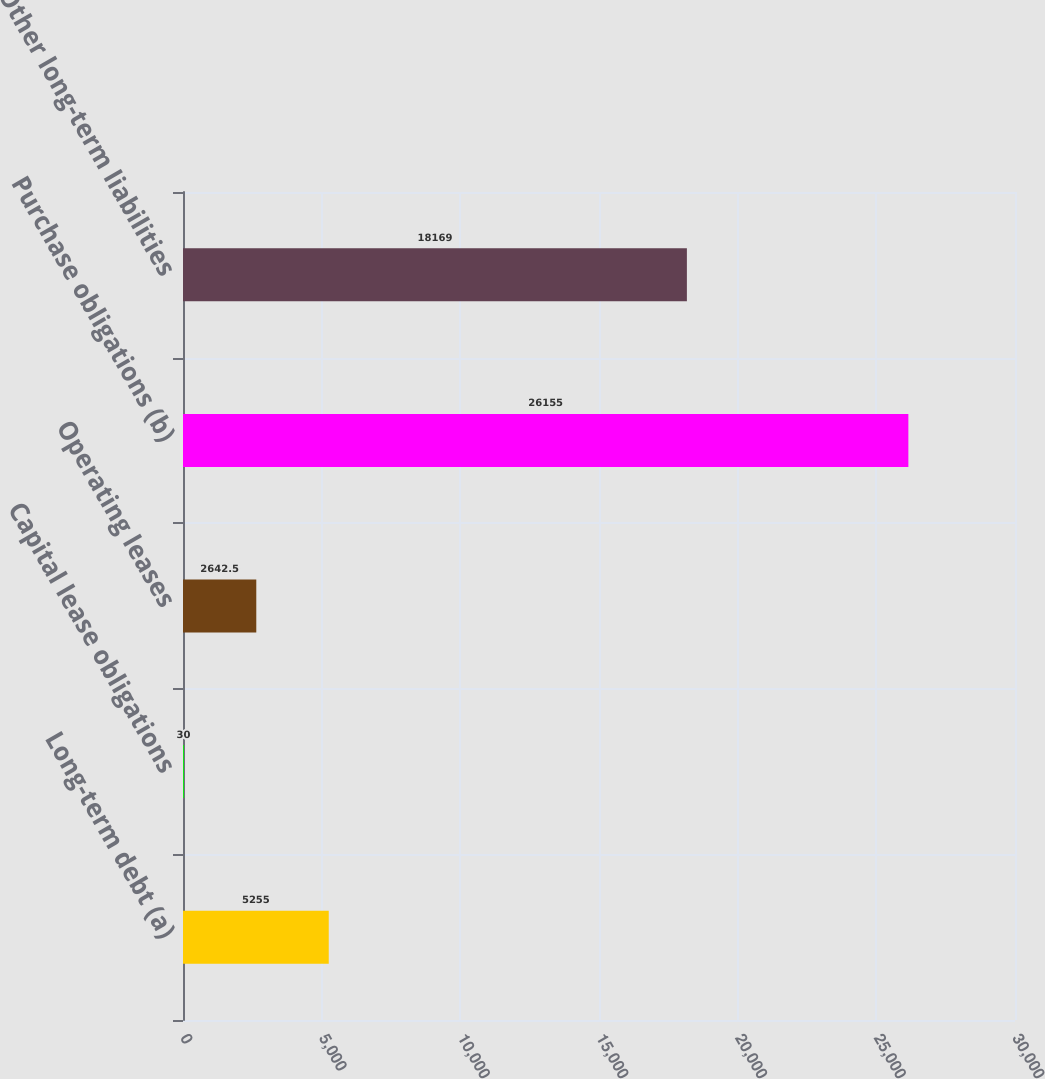Convert chart. <chart><loc_0><loc_0><loc_500><loc_500><bar_chart><fcel>Long-term debt (a)<fcel>Capital lease obligations<fcel>Operating leases<fcel>Purchase obligations (b)<fcel>Other long-term liabilities<nl><fcel>5255<fcel>30<fcel>2642.5<fcel>26155<fcel>18169<nl></chart> 